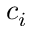Convert formula to latex. <formula><loc_0><loc_0><loc_500><loc_500>c _ { i }</formula> 